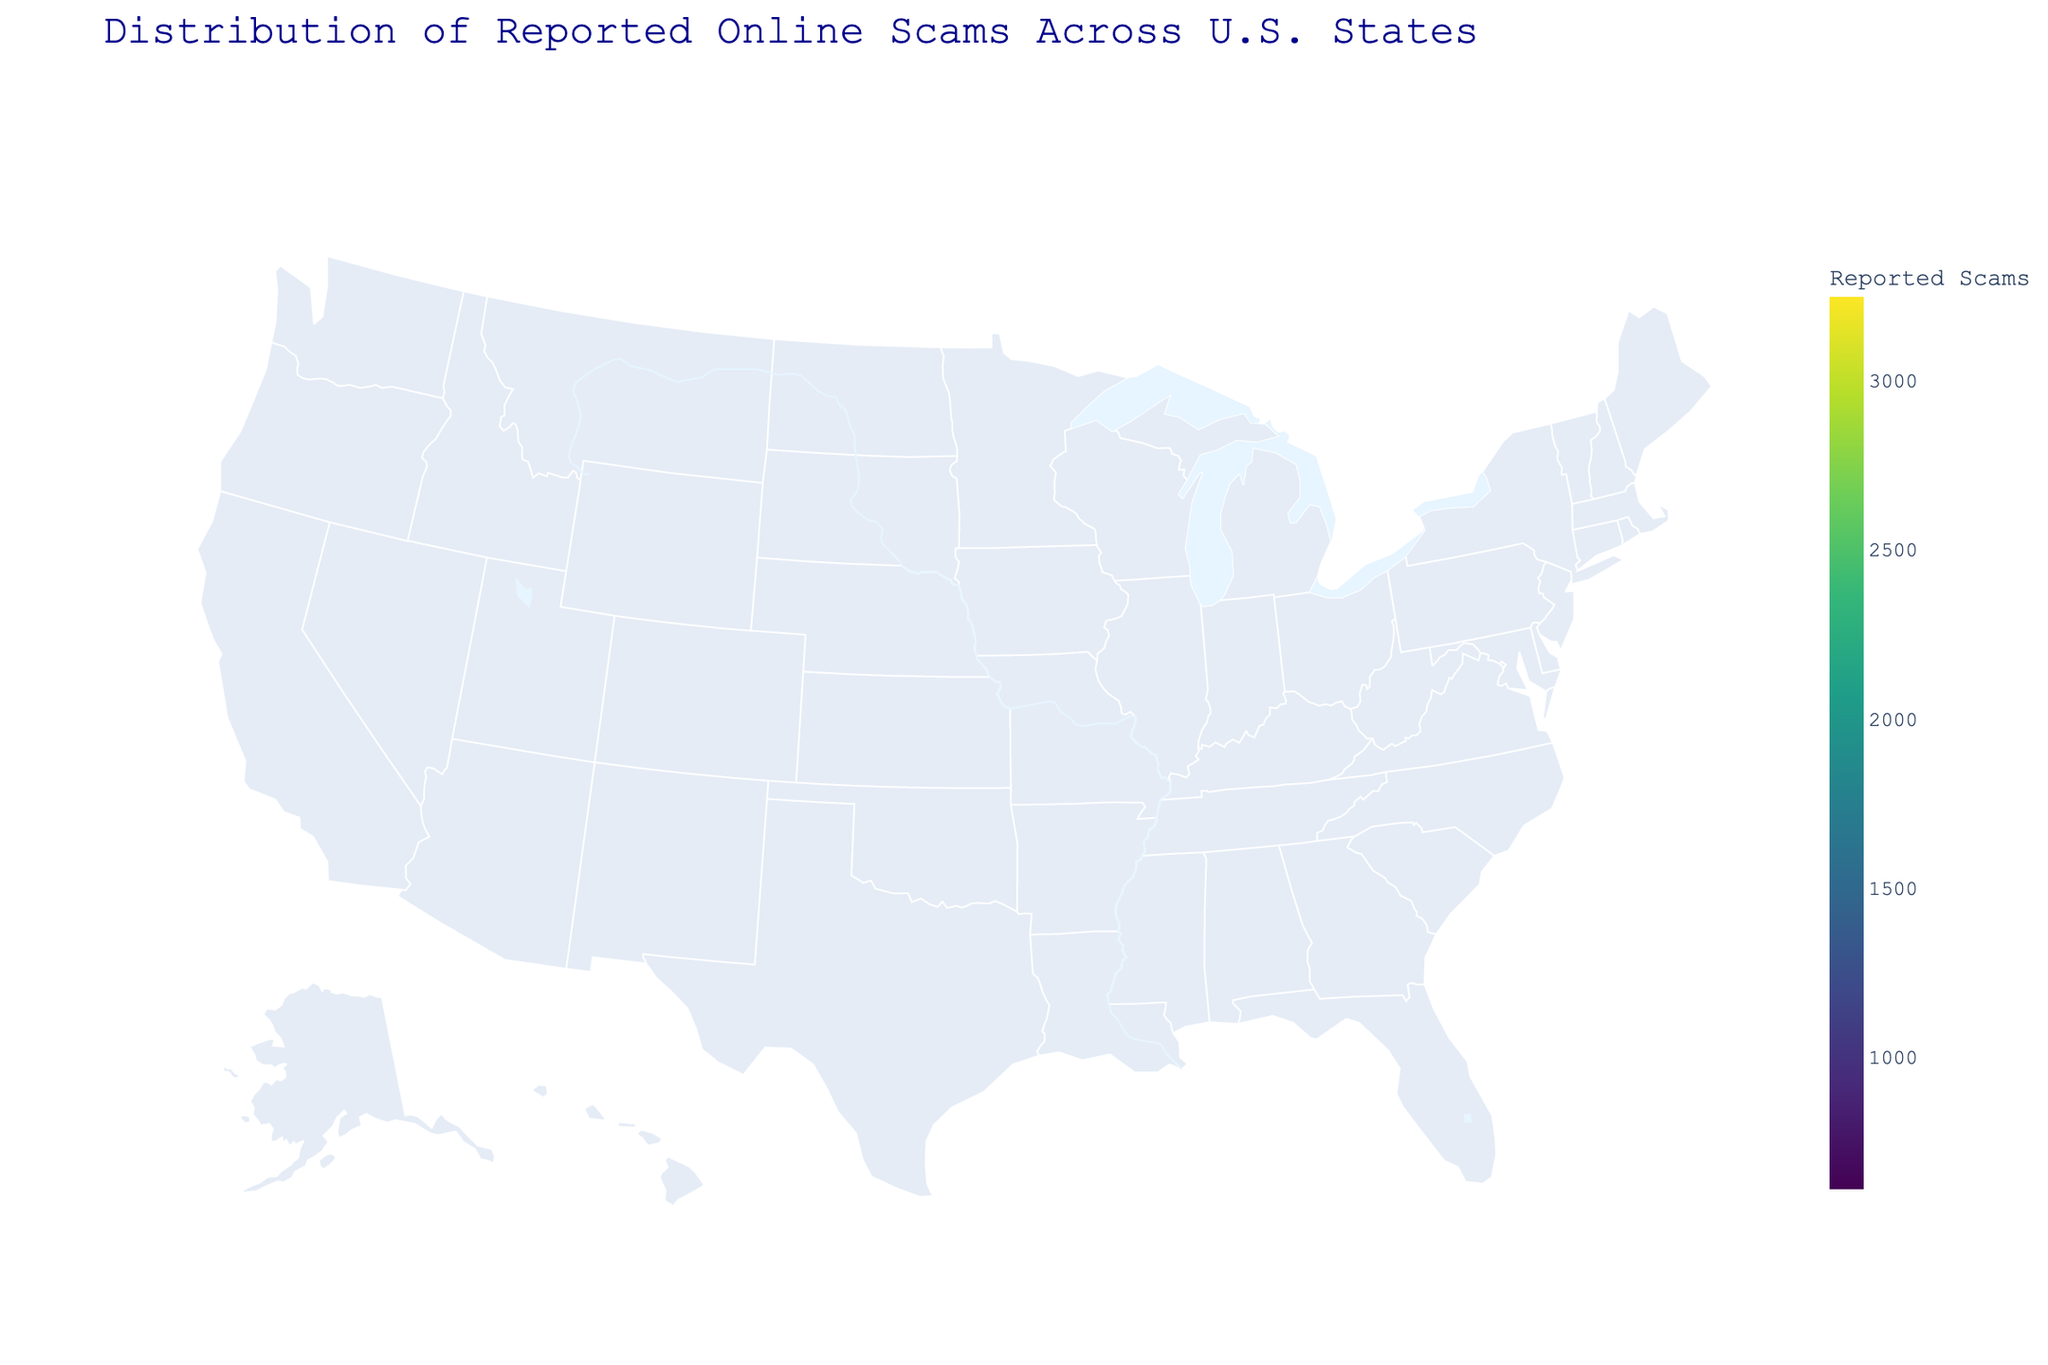What is the state with the highest number of reported scams? Look for the state that has the darkest color, which indicates the highest number of scams. In this plot, California has the darkest shade, meaning it has the highest value.
Answer: California What is the approximate number of reported scams in Texas? Find Texas on the map and check the color intensity which correlates with the legend to estimate the number of scams. Texas has a moderately dark shade, indicating around 2567 reported scams as shown in the data.
Answer: 2567 Which two states have reported scam numbers closest to each other? Look for two states with similar color intensities. Ohio and Michigan have relatively similar shades. According to the data, Ohio has 1321 and Michigan has 1209 reported scams.
Answer: Ohio and Michigan What is the sum of reported scams in New York and Florida? Identify New York and Florida in the plot, note their reported scams from the color legend or data. New York has 2134 scams and Florida has 2890 scams. Sum them together: 2134 + 2890 = 5024.
Answer: 5024 How many states have reported scams greater than 2000? Look at the states with darker shades that reflect numbers above 2000 according to the legend. From the data, California, Florida, Texas, and New York have scams above 2000.
Answer: 4 Which state has the lightest shade in terms of reported scams? Identify the state with the lightest color representing the lowest number of scams. From the data, Wisconsin has the lowest number with 612 reported scams.
Answer: Wisconsin Is Michigan's reported scams count higher than that of Georgia? Compare the color intensities of Michigan and Georgia. Michigan has a reported scam count of 1209, while Georgia has 1187.
Answer: Yes What is the average number of reported scams in Pennsylvania, Illinois, and Ohio? Sum the reported scams for Pennsylvania (1543), Illinois (1432), and Ohio (1321). 1543 + 1432 + 1321 = 4296. Divide by 3 to find the average: 4296 / 3 = 1432.
Answer: 1432 Which region appears to have the most states with high reported scams? From the plot, it can be observed that the western region, particularly the southern part of it, has states with higher reported scams like California and Arizona showing darker shades.
Answer: Western region 